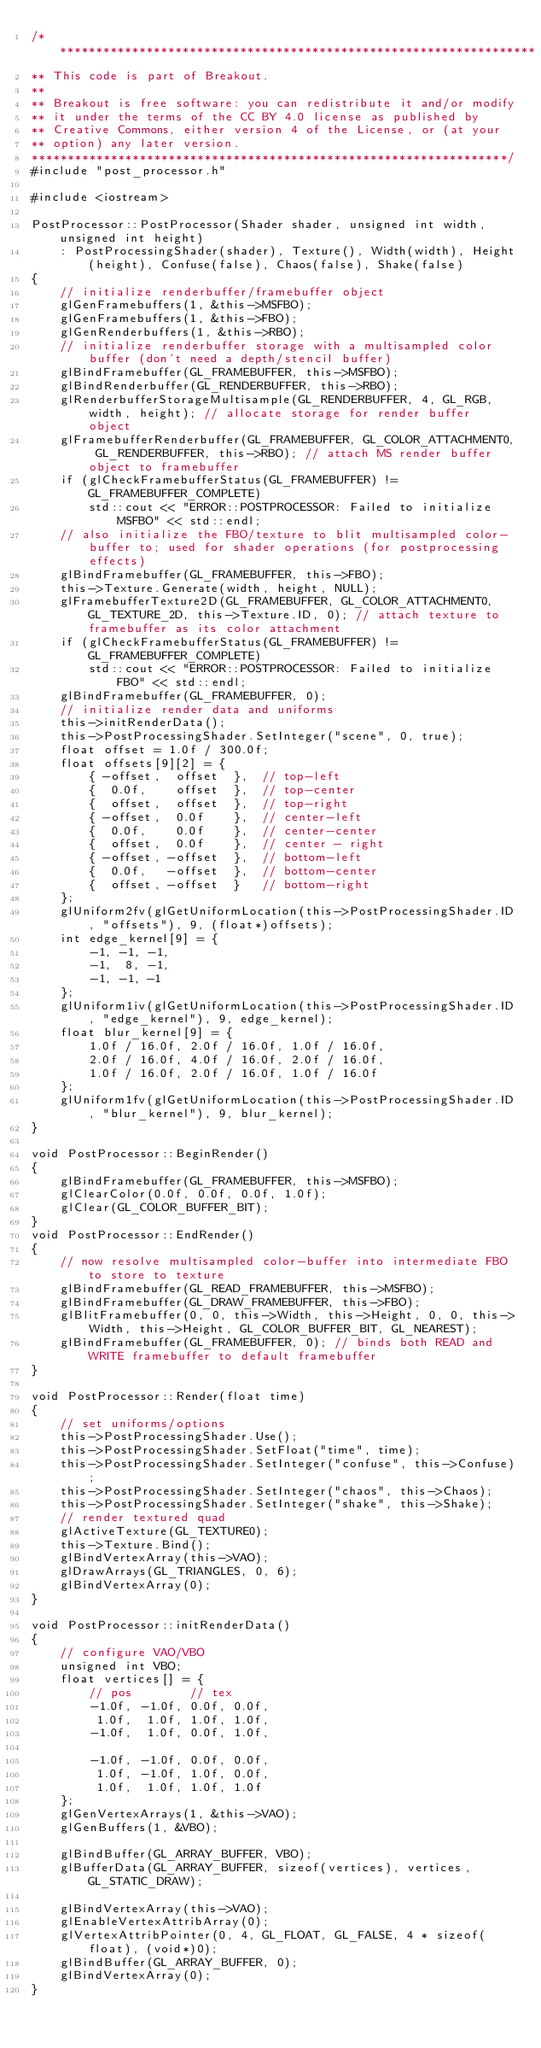Convert code to text. <code><loc_0><loc_0><loc_500><loc_500><_C++_>/*******************************************************************
** This code is part of Breakout.
**
** Breakout is free software: you can redistribute it and/or modify
** it under the terms of the CC BY 4.0 license as published by
** Creative Commons, either version 4 of the License, or (at your
** option) any later version.
******************************************************************/
#include "post_processor.h"

#include <iostream>

PostProcessor::PostProcessor(Shader shader, unsigned int width, unsigned int height) 
    : PostProcessingShader(shader), Texture(), Width(width), Height(height), Confuse(false), Chaos(false), Shake(false)
{
    // initialize renderbuffer/framebuffer object
    glGenFramebuffers(1, &this->MSFBO);
    glGenFramebuffers(1, &this->FBO);
    glGenRenderbuffers(1, &this->RBO);
    // initialize renderbuffer storage with a multisampled color buffer (don't need a depth/stencil buffer)
    glBindFramebuffer(GL_FRAMEBUFFER, this->MSFBO);
    glBindRenderbuffer(GL_RENDERBUFFER, this->RBO);
    glRenderbufferStorageMultisample(GL_RENDERBUFFER, 4, GL_RGB, width, height); // allocate storage for render buffer object
    glFramebufferRenderbuffer(GL_FRAMEBUFFER, GL_COLOR_ATTACHMENT0, GL_RENDERBUFFER, this->RBO); // attach MS render buffer object to framebuffer
    if (glCheckFramebufferStatus(GL_FRAMEBUFFER) != GL_FRAMEBUFFER_COMPLETE)
        std::cout << "ERROR::POSTPROCESSOR: Failed to initialize MSFBO" << std::endl;
    // also initialize the FBO/texture to blit multisampled color-buffer to; used for shader operations (for postprocessing effects)
    glBindFramebuffer(GL_FRAMEBUFFER, this->FBO);
    this->Texture.Generate(width, height, NULL);
    glFramebufferTexture2D(GL_FRAMEBUFFER, GL_COLOR_ATTACHMENT0, GL_TEXTURE_2D, this->Texture.ID, 0); // attach texture to framebuffer as its color attachment
    if (glCheckFramebufferStatus(GL_FRAMEBUFFER) != GL_FRAMEBUFFER_COMPLETE)
        std::cout << "ERROR::POSTPROCESSOR: Failed to initialize FBO" << std::endl;
    glBindFramebuffer(GL_FRAMEBUFFER, 0);
    // initialize render data and uniforms
    this->initRenderData();
    this->PostProcessingShader.SetInteger("scene", 0, true);
    float offset = 1.0f / 300.0f;
    float offsets[9][2] = {
        { -offset,  offset  },  // top-left
        {  0.0f,    offset  },  // top-center
        {  offset,  offset  },  // top-right
        { -offset,  0.0f    },  // center-left
        {  0.0f,    0.0f    },  // center-center
        {  offset,  0.0f    },  // center - right
        { -offset, -offset  },  // bottom-left
        {  0.0f,   -offset  },  // bottom-center
        {  offset, -offset  }   // bottom-right    
    };
    glUniform2fv(glGetUniformLocation(this->PostProcessingShader.ID, "offsets"), 9, (float*)offsets);
    int edge_kernel[9] = {
        -1, -1, -1,
        -1,  8, -1,
        -1, -1, -1
    };
    glUniform1iv(glGetUniformLocation(this->PostProcessingShader.ID, "edge_kernel"), 9, edge_kernel);
    float blur_kernel[9] = {
        1.0f / 16.0f, 2.0f / 16.0f, 1.0f / 16.0f,
        2.0f / 16.0f, 4.0f / 16.0f, 2.0f / 16.0f,
        1.0f / 16.0f, 2.0f / 16.0f, 1.0f / 16.0f
    };
    glUniform1fv(glGetUniformLocation(this->PostProcessingShader.ID, "blur_kernel"), 9, blur_kernel);    
}

void PostProcessor::BeginRender()
{
    glBindFramebuffer(GL_FRAMEBUFFER, this->MSFBO);
    glClearColor(0.0f, 0.0f, 0.0f, 1.0f);
    glClear(GL_COLOR_BUFFER_BIT);
}
void PostProcessor::EndRender()
{
    // now resolve multisampled color-buffer into intermediate FBO to store to texture
    glBindFramebuffer(GL_READ_FRAMEBUFFER, this->MSFBO);
    glBindFramebuffer(GL_DRAW_FRAMEBUFFER, this->FBO);
    glBlitFramebuffer(0, 0, this->Width, this->Height, 0, 0, this->Width, this->Height, GL_COLOR_BUFFER_BIT, GL_NEAREST);
    glBindFramebuffer(GL_FRAMEBUFFER, 0); // binds both READ and WRITE framebuffer to default framebuffer
}

void PostProcessor::Render(float time)
{
    // set uniforms/options
    this->PostProcessingShader.Use();
    this->PostProcessingShader.SetFloat("time", time);
    this->PostProcessingShader.SetInteger("confuse", this->Confuse);
    this->PostProcessingShader.SetInteger("chaos", this->Chaos);
    this->PostProcessingShader.SetInteger("shake", this->Shake);
    // render textured quad
    glActiveTexture(GL_TEXTURE0);
    this->Texture.Bind();	
    glBindVertexArray(this->VAO);
    glDrawArrays(GL_TRIANGLES, 0, 6);
    glBindVertexArray(0);
}

void PostProcessor::initRenderData()
{
    // configure VAO/VBO
    unsigned int VBO;
    float vertices[] = {
        // pos        // tex
        -1.0f, -1.0f, 0.0f, 0.0f,
         1.0f,  1.0f, 1.0f, 1.0f,
        -1.0f,  1.0f, 0.0f, 1.0f,

        -1.0f, -1.0f, 0.0f, 0.0f,
         1.0f, -1.0f, 1.0f, 0.0f,
         1.0f,  1.0f, 1.0f, 1.0f
    };
    glGenVertexArrays(1, &this->VAO);
    glGenBuffers(1, &VBO);

    glBindBuffer(GL_ARRAY_BUFFER, VBO);
    glBufferData(GL_ARRAY_BUFFER, sizeof(vertices), vertices, GL_STATIC_DRAW);

    glBindVertexArray(this->VAO);
    glEnableVertexAttribArray(0);
    glVertexAttribPointer(0, 4, GL_FLOAT, GL_FALSE, 4 * sizeof(float), (void*)0);
    glBindBuffer(GL_ARRAY_BUFFER, 0);
    glBindVertexArray(0);
}</code> 